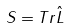Convert formula to latex. <formula><loc_0><loc_0><loc_500><loc_500>S = T r \hat { L }</formula> 